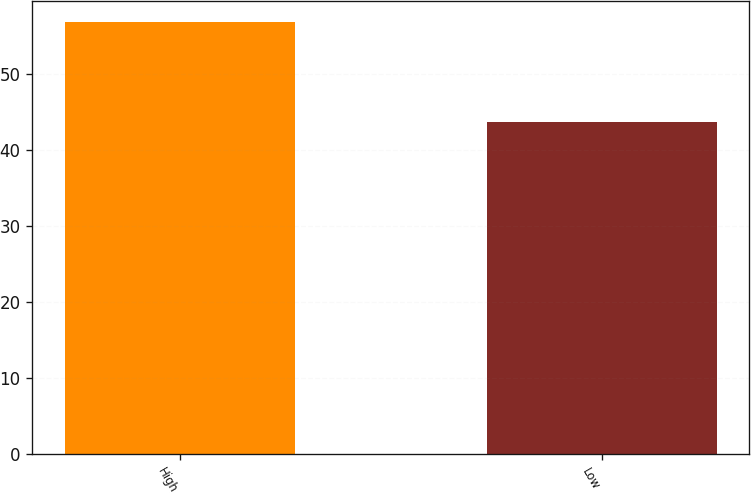<chart> <loc_0><loc_0><loc_500><loc_500><bar_chart><fcel>High<fcel>Low<nl><fcel>56.85<fcel>43.75<nl></chart> 